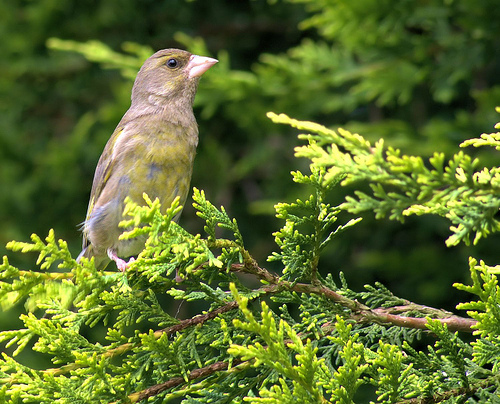How many birds are in the picture? There is one bird in the picture. It appears to be perched thoughtfully among the branches of a vibrant green bush, potentially scanning the surroundings or simply taking a moment to rest. 